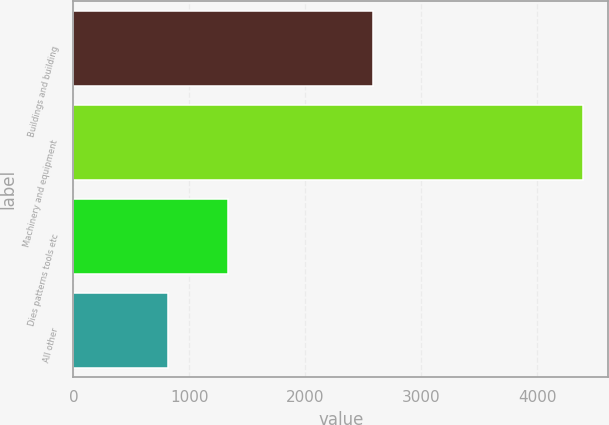Convert chart to OTSL. <chart><loc_0><loc_0><loc_500><loc_500><bar_chart><fcel>Buildings and building<fcel>Machinery and equipment<fcel>Dies patterns tools etc<fcel>All other<nl><fcel>2584<fcel>4393<fcel>1330<fcel>819<nl></chart> 